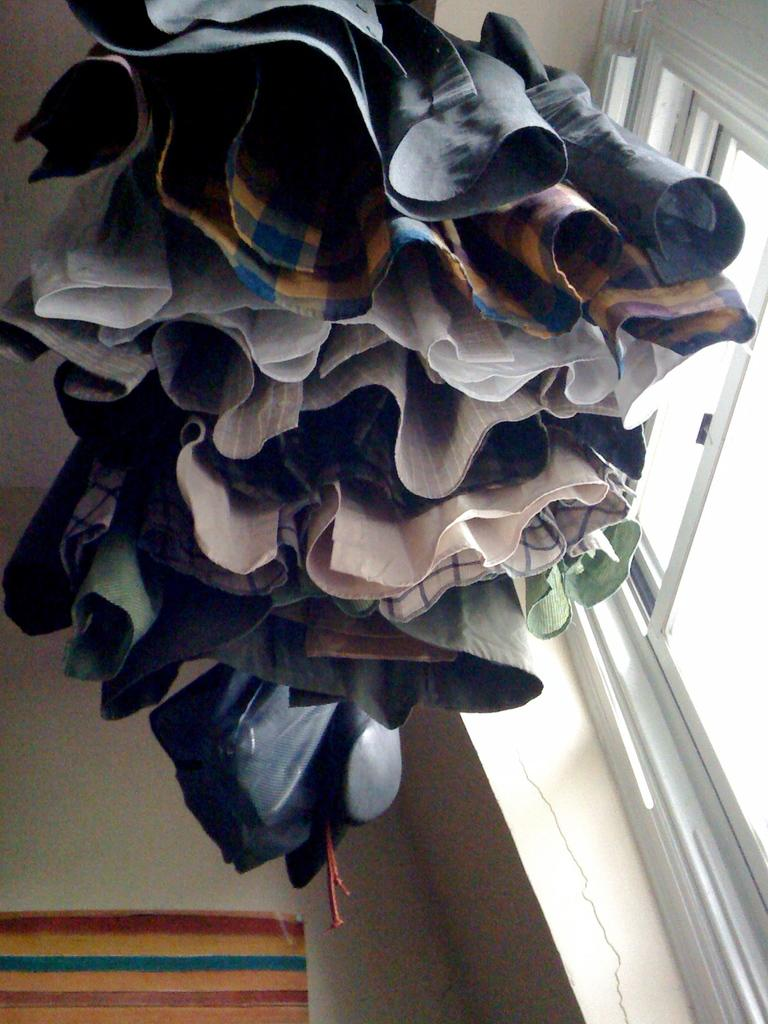What is hanging in the image? There are clothes hanged in the image. What can be seen through the window in the image? The image does not show what can be seen through the window. What is located next to the window in the image? There is a wall adjacent to the window in the image. What type of creature is shown interacting with the clothes in the image? There is no creature shown interacting with the clothes in the image; the clothes are simply hanging. What kind of laborer is working near the wall in the image? There is no laborer present in the image; it only shows clothes hanging and a wall adjacent to the window. 